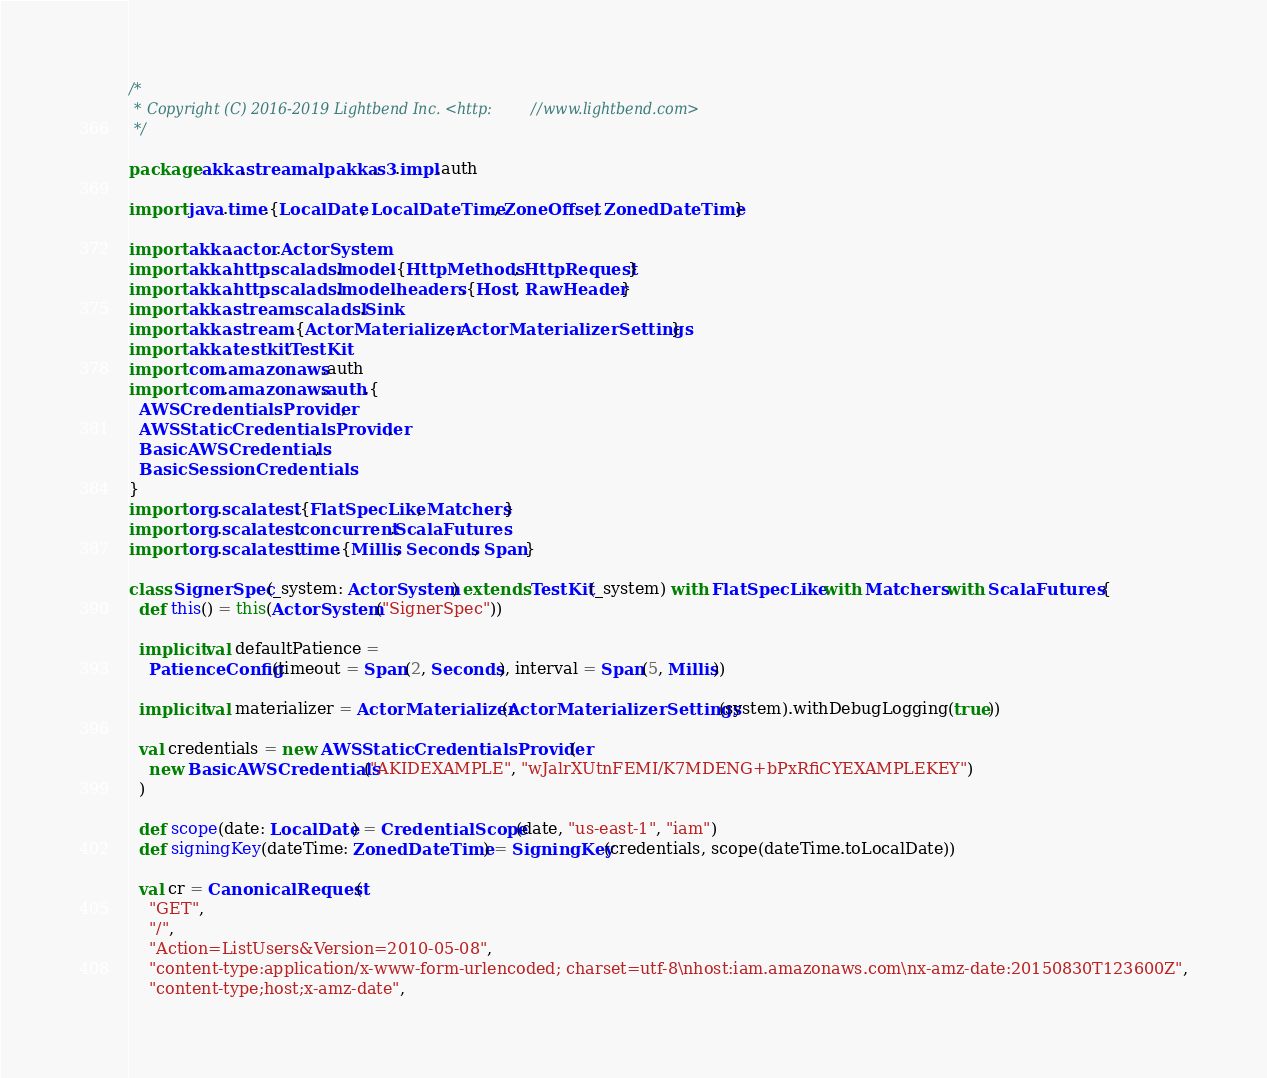Convert code to text. <code><loc_0><loc_0><loc_500><loc_500><_Scala_>/*
 * Copyright (C) 2016-2019 Lightbend Inc. <http://www.lightbend.com>
 */

package akka.stream.alpakka.s3.impl.auth

import java.time.{LocalDate, LocalDateTime, ZoneOffset, ZonedDateTime}

import akka.actor.ActorSystem
import akka.http.scaladsl.model.{HttpMethods, HttpRequest}
import akka.http.scaladsl.model.headers.{Host, RawHeader}
import akka.stream.scaladsl.Sink
import akka.stream.{ActorMaterializer, ActorMaterializerSettings}
import akka.testkit.TestKit
import com.amazonaws.auth
import com.amazonaws.auth.{
  AWSCredentialsProvider,
  AWSStaticCredentialsProvider,
  BasicAWSCredentials,
  BasicSessionCredentials
}
import org.scalatest.{FlatSpecLike, Matchers}
import org.scalatest.concurrent.ScalaFutures
import org.scalatest.time.{Millis, Seconds, Span}

class SignerSpec(_system: ActorSystem) extends TestKit(_system) with FlatSpecLike with Matchers with ScalaFutures {
  def this() = this(ActorSystem("SignerSpec"))

  implicit val defaultPatience =
    PatienceConfig(timeout = Span(2, Seconds), interval = Span(5, Millis))

  implicit val materializer = ActorMaterializer(ActorMaterializerSettings(system).withDebugLogging(true))

  val credentials = new AWSStaticCredentialsProvider(
    new BasicAWSCredentials("AKIDEXAMPLE", "wJalrXUtnFEMI/K7MDENG+bPxRfiCYEXAMPLEKEY")
  )

  def scope(date: LocalDate) = CredentialScope(date, "us-east-1", "iam")
  def signingKey(dateTime: ZonedDateTime) = SigningKey(credentials, scope(dateTime.toLocalDate))

  val cr = CanonicalRequest(
    "GET",
    "/",
    "Action=ListUsers&Version=2010-05-08",
    "content-type:application/x-www-form-urlencoded; charset=utf-8\nhost:iam.amazonaws.com\nx-amz-date:20150830T123600Z",
    "content-type;host;x-amz-date",</code> 